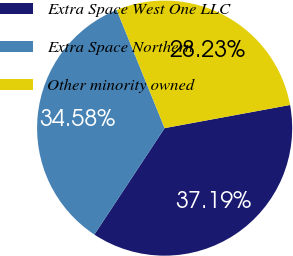Convert chart. <chart><loc_0><loc_0><loc_500><loc_500><pie_chart><fcel>Extra Space West One LLC<fcel>Extra Space Northern<fcel>Other minority owned<nl><fcel>37.19%<fcel>34.58%<fcel>28.23%<nl></chart> 